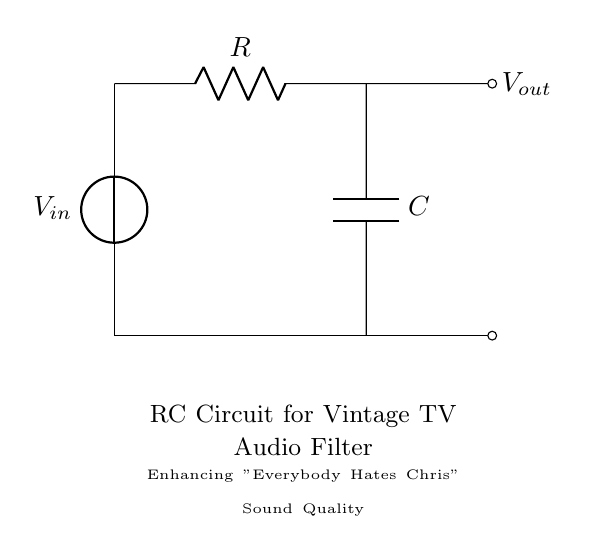What type of circuit is represented? This circuit is an RC circuit, as it consists of a resistor (R) and a capacitor (C) connected in series with a voltage source.
Answer: RC circuit What is the output voltage node labeled as? The output voltage node is labeled as V out, which indicates the point where the voltage is measured across the capacitor.
Answer: V out What component enhances audio quality in this circuit? The capacitor (C) is used to filter audio signals, allowing specific frequencies to pass while attenuating others, effectively enhancing sound quality.
Answer: Capacitor What does the resistor do in this circuit? The resistor (R) limits the amount of current flowing through the circuit, which affects the charging and discharging time of the capacitor and thus influences the frequency response.
Answer: Limits current What is the relationship between resistance and cutoff frequency in this circuit? The cutoff frequency is inversely related to the product of resistance and capacitance. Increasing resistance decreases cutoff frequency, allowing lower frequencies to pass.
Answer: Inversely related How does this circuit affect high-frequency signals? The RC circuit attenuates high-frequency signals more than low-frequency signals due to its frequency-dependent response, allowing it to filter the audio output accordingly.
Answer: Attenuates high frequencies 